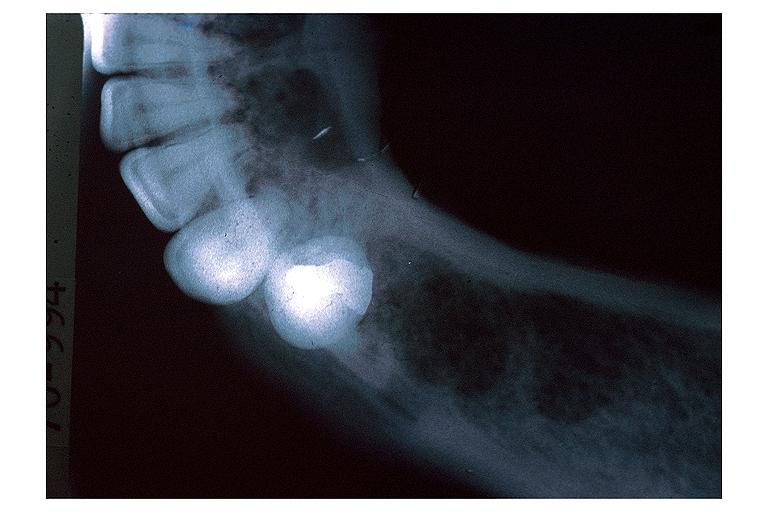does this image show lymphoma?
Answer the question using a single word or phrase. Yes 